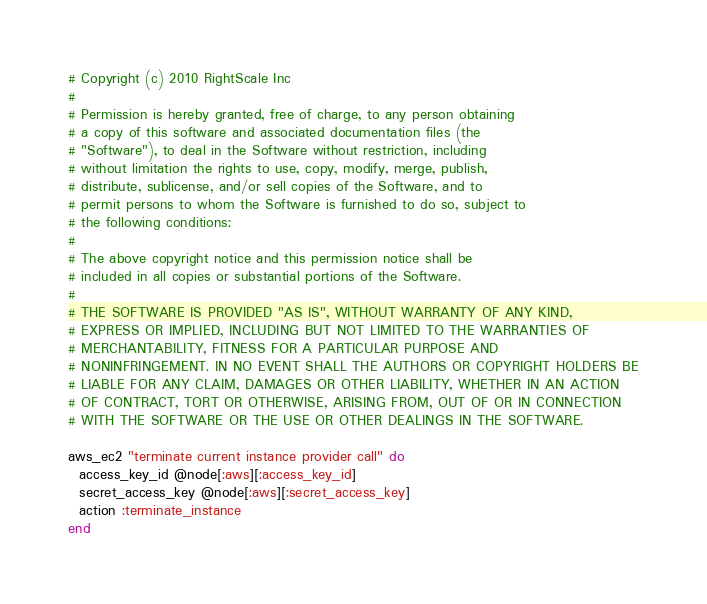<code> <loc_0><loc_0><loc_500><loc_500><_Ruby_># Copyright (c) 2010 RightScale Inc
#
# Permission is hereby granted, free of charge, to any person obtaining
# a copy of this software and associated documentation files (the
# "Software"), to deal in the Software without restriction, including
# without limitation the rights to use, copy, modify, merge, publish,
# distribute, sublicense, and/or sell copies of the Software, and to
# permit persons to whom the Software is furnished to do so, subject to
# the following conditions:
#
# The above copyright notice and this permission notice shall be
# included in all copies or substantial portions of the Software.
#
# THE SOFTWARE IS PROVIDED "AS IS", WITHOUT WARRANTY OF ANY KIND,
# EXPRESS OR IMPLIED, INCLUDING BUT NOT LIMITED TO THE WARRANTIES OF
# MERCHANTABILITY, FITNESS FOR A PARTICULAR PURPOSE AND
# NONINFRINGEMENT. IN NO EVENT SHALL THE AUTHORS OR COPYRIGHT HOLDERS BE
# LIABLE FOR ANY CLAIM, DAMAGES OR OTHER LIABILITY, WHETHER IN AN ACTION
# OF CONTRACT, TORT OR OTHERWISE, ARISING FROM, OUT OF OR IN CONNECTION
# WITH THE SOFTWARE OR THE USE OR OTHER DEALINGS IN THE SOFTWARE.

aws_ec2 "terminate current instance provider call" do
  access_key_id @node[:aws][:access_key_id]
  secret_access_key @node[:aws][:secret_access_key]
  action :terminate_instance
end</code> 